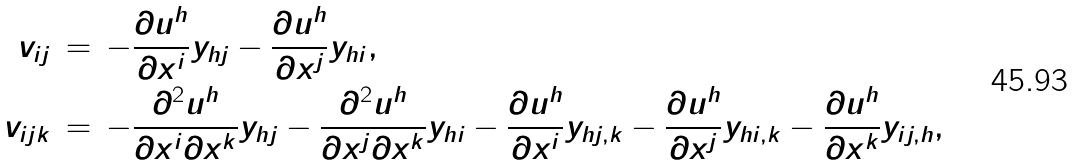<formula> <loc_0><loc_0><loc_500><loc_500>v _ { i j } \, & = \, - \frac { \partial u ^ { h } } { \partial x ^ { i } } y _ { h j } - \frac { \partial u ^ { h } } { \partial x ^ { j } } y _ { h i } , \\ v _ { i j k } \, & = \, - \frac { \partial ^ { 2 } u ^ { h } } { \partial x ^ { i } \partial x ^ { k } } y _ { h j } - \frac { \partial ^ { 2 } u ^ { h } } { \partial x ^ { j } \partial x ^ { k } } y _ { h i } - \frac { \partial u ^ { h } } { \partial x ^ { i } } y _ { h j , k } - \frac { \partial u ^ { h } } { \partial x ^ { j } } y _ { h i , k } - \frac { \partial u ^ { h } } { \partial x ^ { k } } y _ { i j , h } ,</formula> 